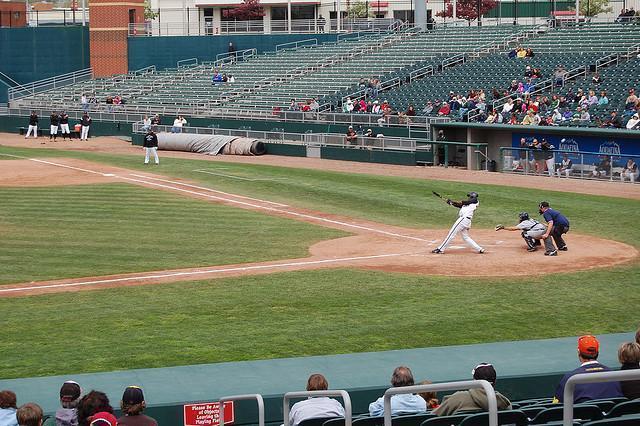How many players in baseball team?
Indicate the correct response and explain using: 'Answer: answer
Rationale: rationale.'
Options: 12, 11, eight, nine. Answer: nine.
Rationale: 6 are infield and 3 outfield 